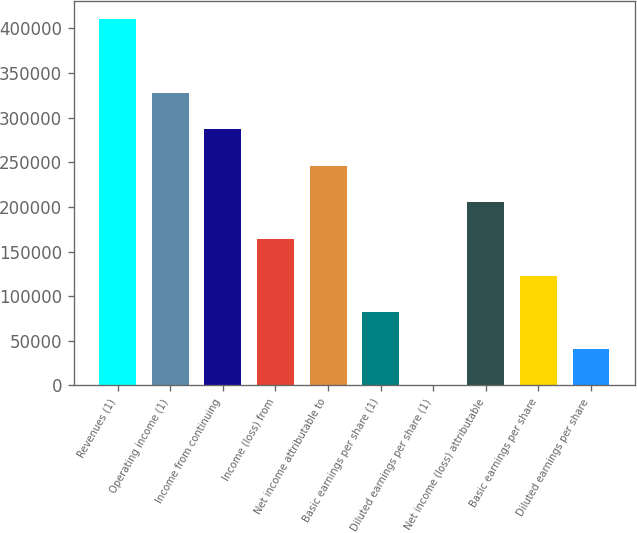Convert chart to OTSL. <chart><loc_0><loc_0><loc_500><loc_500><bar_chart><fcel>Revenues (1)<fcel>Operating income (1)<fcel>Income from continuing<fcel>Income (loss) from<fcel>Net income attributable to<fcel>Basic earnings per share (1)<fcel>Diluted earnings per share (1)<fcel>Net income (loss) attributable<fcel>Basic earnings per share<fcel>Diluted earnings per share<nl><fcel>409932<fcel>327946<fcel>286953<fcel>163973<fcel>245959<fcel>81987<fcel>0.71<fcel>204966<fcel>122980<fcel>40993.8<nl></chart> 